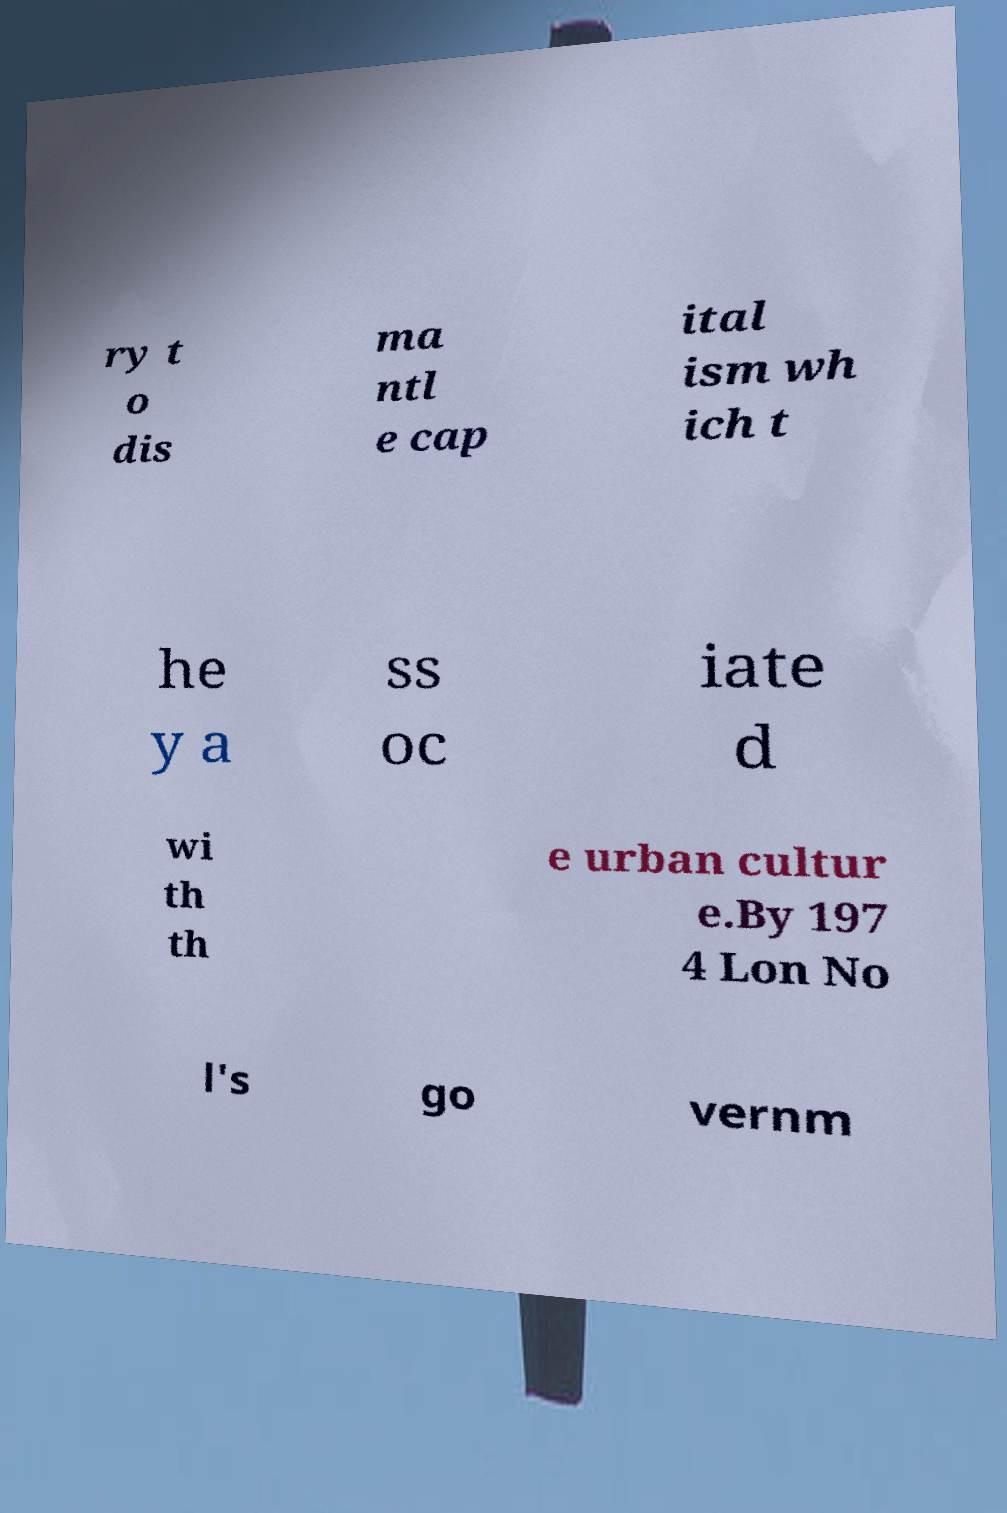Please identify and transcribe the text found in this image. ry t o dis ma ntl e cap ital ism wh ich t he y a ss oc iate d wi th th e urban cultur e.By 197 4 Lon No l's go vernm 